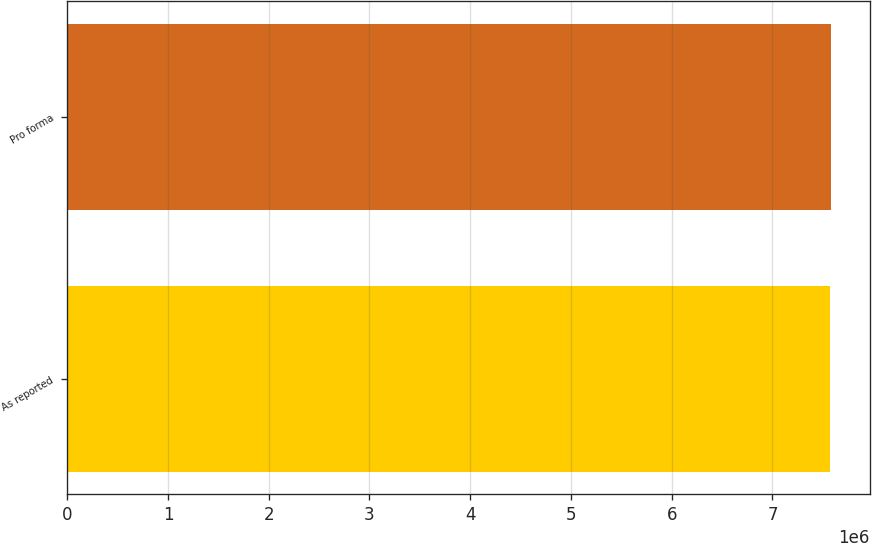<chart> <loc_0><loc_0><loc_500><loc_500><bar_chart><fcel>As reported<fcel>Pro forma<nl><fcel>7.56889e+06<fcel>7.58666e+06<nl></chart> 